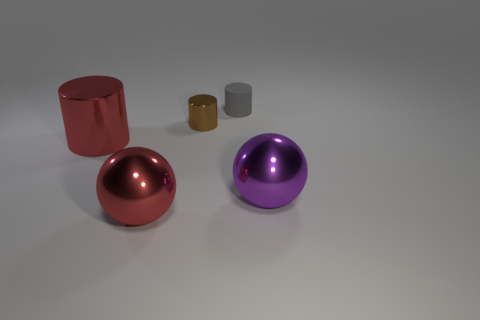Add 5 big cylinders. How many objects exist? 10 Add 3 green balls. How many green balls exist? 3 Subtract all brown cylinders. How many cylinders are left? 2 Subtract all tiny gray cylinders. How many cylinders are left? 2 Subtract 0 cyan balls. How many objects are left? 5 Subtract all cylinders. How many objects are left? 2 Subtract 2 balls. How many balls are left? 0 Subtract all green cylinders. Subtract all purple spheres. How many cylinders are left? 3 Subtract all gray balls. How many green cylinders are left? 0 Subtract all matte objects. Subtract all large brown matte objects. How many objects are left? 4 